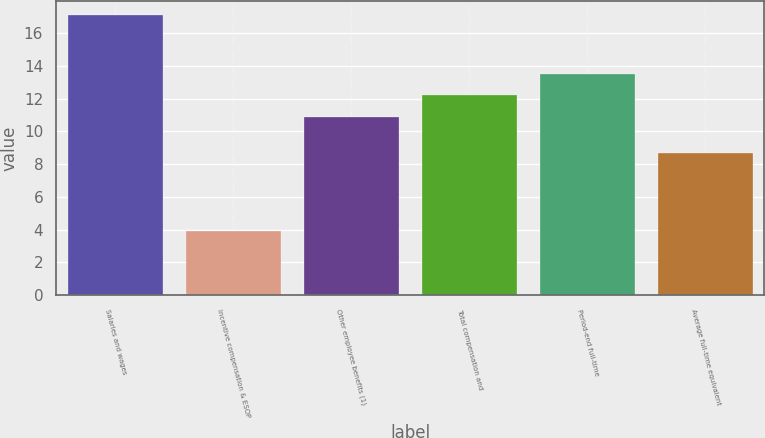<chart> <loc_0><loc_0><loc_500><loc_500><bar_chart><fcel>Salaries and wages<fcel>Incentive compensation & ESOP<fcel>Other employee benefits (1)<fcel>Total compensation and<fcel>Period-end full-time<fcel>Average full-time equivalent<nl><fcel>17.1<fcel>3.9<fcel>10.9<fcel>12.22<fcel>13.54<fcel>8.7<nl></chart> 